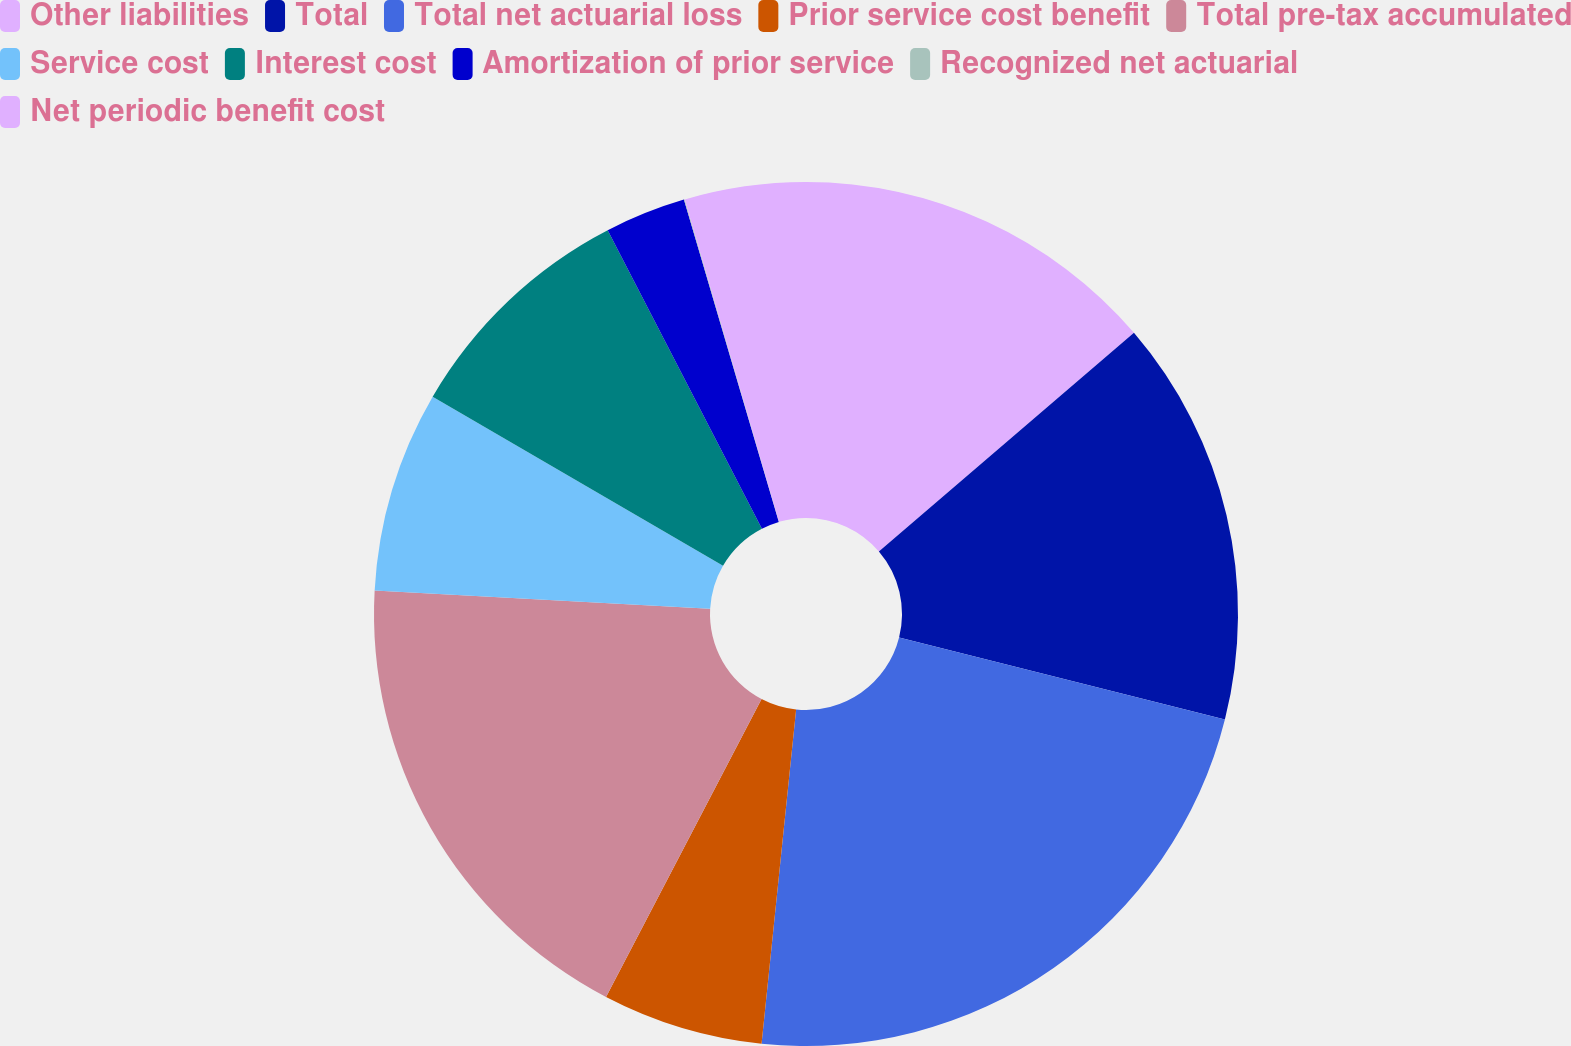Convert chart. <chart><loc_0><loc_0><loc_500><loc_500><pie_chart><fcel>Other liabilities<fcel>Total<fcel>Total net actuarial loss<fcel>Prior service cost benefit<fcel>Total pre-tax accumulated<fcel>Service cost<fcel>Interest cost<fcel>Amortization of prior service<fcel>Recognized net actuarial<fcel>Net periodic benefit cost<nl><fcel>13.72%<fcel>15.21%<fcel>22.71%<fcel>6.02%<fcel>18.21%<fcel>7.52%<fcel>9.02%<fcel>3.03%<fcel>0.03%<fcel>4.53%<nl></chart> 